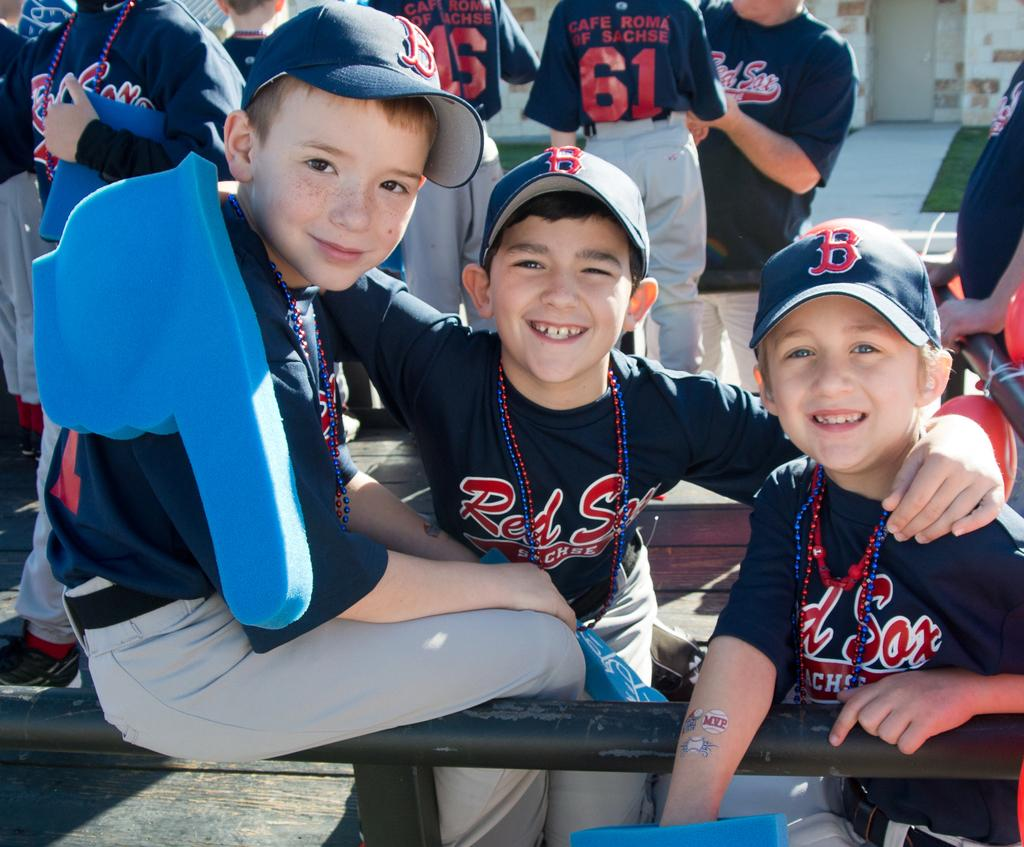<image>
Create a compact narrative representing the image presented. group of little league players wearing red sox uniforms sponsored by cafe roma of sachse 